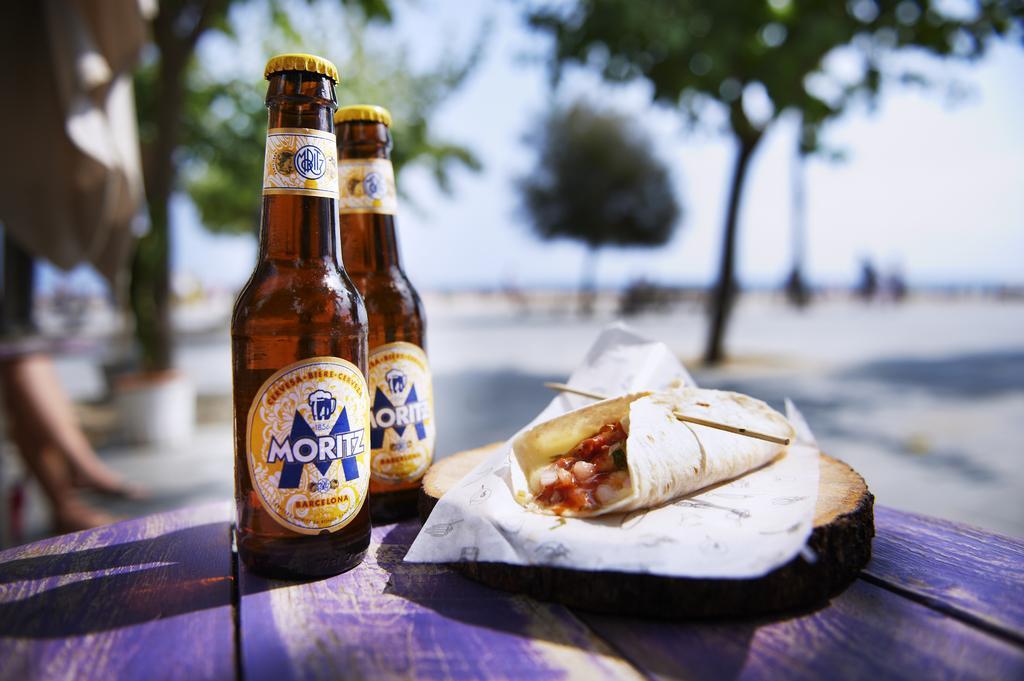Could you give a brief overview of what you see in this image? This picture shows two beer bottles and some food on the table and we see few trees around 